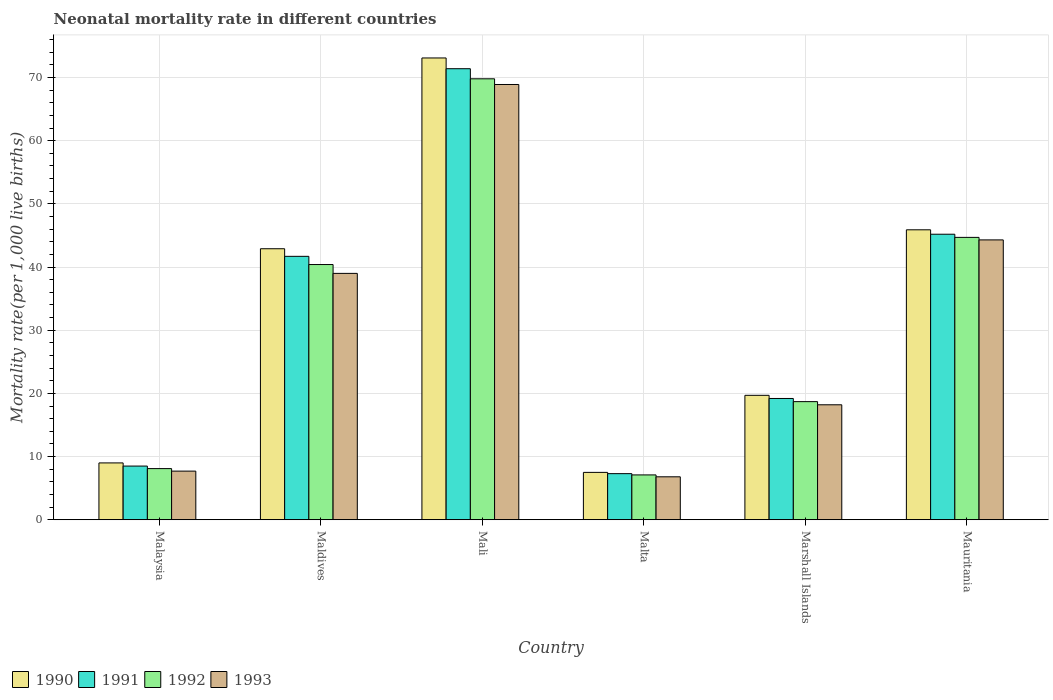How many different coloured bars are there?
Make the answer very short. 4. How many groups of bars are there?
Make the answer very short. 6. What is the label of the 3rd group of bars from the left?
Offer a very short reply. Mali. In how many cases, is the number of bars for a given country not equal to the number of legend labels?
Provide a succinct answer. 0. What is the neonatal mortality rate in 1992 in Mali?
Ensure brevity in your answer.  69.8. Across all countries, what is the maximum neonatal mortality rate in 1990?
Your answer should be compact. 73.1. In which country was the neonatal mortality rate in 1991 maximum?
Provide a short and direct response. Mali. In which country was the neonatal mortality rate in 1993 minimum?
Your response must be concise. Malta. What is the total neonatal mortality rate in 1992 in the graph?
Provide a short and direct response. 188.8. What is the difference between the neonatal mortality rate in 1990 in Maldives and that in Malta?
Give a very brief answer. 35.4. What is the difference between the neonatal mortality rate in 1992 in Mauritania and the neonatal mortality rate in 1991 in Malta?
Your response must be concise. 37.4. What is the average neonatal mortality rate in 1990 per country?
Ensure brevity in your answer.  33.02. What is the difference between the neonatal mortality rate of/in 1992 and neonatal mortality rate of/in 1993 in Malta?
Your response must be concise. 0.3. In how many countries, is the neonatal mortality rate in 1990 greater than 36?
Your response must be concise. 3. What is the ratio of the neonatal mortality rate in 1992 in Mali to that in Malta?
Provide a succinct answer. 9.83. Is the difference between the neonatal mortality rate in 1992 in Malaysia and Maldives greater than the difference between the neonatal mortality rate in 1993 in Malaysia and Maldives?
Your answer should be very brief. No. What is the difference between the highest and the second highest neonatal mortality rate in 1991?
Offer a terse response. -3.5. What is the difference between the highest and the lowest neonatal mortality rate in 1993?
Offer a very short reply. 62.1. Is the sum of the neonatal mortality rate in 1991 in Maldives and Marshall Islands greater than the maximum neonatal mortality rate in 1992 across all countries?
Your answer should be very brief. No. What does the 2nd bar from the right in Mali represents?
Offer a terse response. 1992. How many countries are there in the graph?
Offer a very short reply. 6. What is the difference between two consecutive major ticks on the Y-axis?
Give a very brief answer. 10. Are the values on the major ticks of Y-axis written in scientific E-notation?
Your answer should be very brief. No. Does the graph contain grids?
Provide a short and direct response. Yes. How many legend labels are there?
Your answer should be compact. 4. What is the title of the graph?
Your answer should be compact. Neonatal mortality rate in different countries. Does "2015" appear as one of the legend labels in the graph?
Ensure brevity in your answer.  No. What is the label or title of the X-axis?
Your answer should be very brief. Country. What is the label or title of the Y-axis?
Your answer should be compact. Mortality rate(per 1,0 live births). What is the Mortality rate(per 1,000 live births) of 1993 in Malaysia?
Make the answer very short. 7.7. What is the Mortality rate(per 1,000 live births) of 1990 in Maldives?
Ensure brevity in your answer.  42.9. What is the Mortality rate(per 1,000 live births) in 1991 in Maldives?
Your answer should be very brief. 41.7. What is the Mortality rate(per 1,000 live births) of 1992 in Maldives?
Ensure brevity in your answer.  40.4. What is the Mortality rate(per 1,000 live births) in 1990 in Mali?
Your response must be concise. 73.1. What is the Mortality rate(per 1,000 live births) of 1991 in Mali?
Your response must be concise. 71.4. What is the Mortality rate(per 1,000 live births) of 1992 in Mali?
Provide a short and direct response. 69.8. What is the Mortality rate(per 1,000 live births) of 1993 in Mali?
Your answer should be compact. 68.9. What is the Mortality rate(per 1,000 live births) in 1990 in Malta?
Provide a short and direct response. 7.5. What is the Mortality rate(per 1,000 live births) in 1991 in Malta?
Make the answer very short. 7.3. What is the Mortality rate(per 1,000 live births) in 1990 in Marshall Islands?
Give a very brief answer. 19.7. What is the Mortality rate(per 1,000 live births) of 1990 in Mauritania?
Make the answer very short. 45.9. What is the Mortality rate(per 1,000 live births) of 1991 in Mauritania?
Ensure brevity in your answer.  45.2. What is the Mortality rate(per 1,000 live births) in 1992 in Mauritania?
Your response must be concise. 44.7. What is the Mortality rate(per 1,000 live births) of 1993 in Mauritania?
Ensure brevity in your answer.  44.3. Across all countries, what is the maximum Mortality rate(per 1,000 live births) of 1990?
Ensure brevity in your answer.  73.1. Across all countries, what is the maximum Mortality rate(per 1,000 live births) of 1991?
Your answer should be compact. 71.4. Across all countries, what is the maximum Mortality rate(per 1,000 live births) of 1992?
Offer a very short reply. 69.8. Across all countries, what is the maximum Mortality rate(per 1,000 live births) of 1993?
Offer a terse response. 68.9. Across all countries, what is the minimum Mortality rate(per 1,000 live births) of 1991?
Offer a terse response. 7.3. Across all countries, what is the minimum Mortality rate(per 1,000 live births) in 1992?
Ensure brevity in your answer.  7.1. What is the total Mortality rate(per 1,000 live births) in 1990 in the graph?
Give a very brief answer. 198.1. What is the total Mortality rate(per 1,000 live births) in 1991 in the graph?
Your answer should be very brief. 193.3. What is the total Mortality rate(per 1,000 live births) of 1992 in the graph?
Your answer should be compact. 188.8. What is the total Mortality rate(per 1,000 live births) of 1993 in the graph?
Ensure brevity in your answer.  184.9. What is the difference between the Mortality rate(per 1,000 live births) of 1990 in Malaysia and that in Maldives?
Your answer should be compact. -33.9. What is the difference between the Mortality rate(per 1,000 live births) of 1991 in Malaysia and that in Maldives?
Provide a succinct answer. -33.2. What is the difference between the Mortality rate(per 1,000 live births) in 1992 in Malaysia and that in Maldives?
Keep it short and to the point. -32.3. What is the difference between the Mortality rate(per 1,000 live births) of 1993 in Malaysia and that in Maldives?
Your answer should be very brief. -31.3. What is the difference between the Mortality rate(per 1,000 live births) of 1990 in Malaysia and that in Mali?
Provide a short and direct response. -64.1. What is the difference between the Mortality rate(per 1,000 live births) of 1991 in Malaysia and that in Mali?
Your answer should be very brief. -62.9. What is the difference between the Mortality rate(per 1,000 live births) of 1992 in Malaysia and that in Mali?
Your answer should be very brief. -61.7. What is the difference between the Mortality rate(per 1,000 live births) in 1993 in Malaysia and that in Mali?
Your answer should be very brief. -61.2. What is the difference between the Mortality rate(per 1,000 live births) in 1991 in Malaysia and that in Malta?
Provide a short and direct response. 1.2. What is the difference between the Mortality rate(per 1,000 live births) of 1993 in Malaysia and that in Malta?
Offer a very short reply. 0.9. What is the difference between the Mortality rate(per 1,000 live births) in 1992 in Malaysia and that in Marshall Islands?
Provide a succinct answer. -10.6. What is the difference between the Mortality rate(per 1,000 live births) in 1993 in Malaysia and that in Marshall Islands?
Provide a succinct answer. -10.5. What is the difference between the Mortality rate(per 1,000 live births) of 1990 in Malaysia and that in Mauritania?
Provide a short and direct response. -36.9. What is the difference between the Mortality rate(per 1,000 live births) of 1991 in Malaysia and that in Mauritania?
Offer a very short reply. -36.7. What is the difference between the Mortality rate(per 1,000 live births) in 1992 in Malaysia and that in Mauritania?
Make the answer very short. -36.6. What is the difference between the Mortality rate(per 1,000 live births) in 1993 in Malaysia and that in Mauritania?
Give a very brief answer. -36.6. What is the difference between the Mortality rate(per 1,000 live births) in 1990 in Maldives and that in Mali?
Provide a succinct answer. -30.2. What is the difference between the Mortality rate(per 1,000 live births) of 1991 in Maldives and that in Mali?
Ensure brevity in your answer.  -29.7. What is the difference between the Mortality rate(per 1,000 live births) in 1992 in Maldives and that in Mali?
Provide a short and direct response. -29.4. What is the difference between the Mortality rate(per 1,000 live births) of 1993 in Maldives and that in Mali?
Provide a short and direct response. -29.9. What is the difference between the Mortality rate(per 1,000 live births) of 1990 in Maldives and that in Malta?
Your response must be concise. 35.4. What is the difference between the Mortality rate(per 1,000 live births) of 1991 in Maldives and that in Malta?
Ensure brevity in your answer.  34.4. What is the difference between the Mortality rate(per 1,000 live births) in 1992 in Maldives and that in Malta?
Offer a very short reply. 33.3. What is the difference between the Mortality rate(per 1,000 live births) of 1993 in Maldives and that in Malta?
Make the answer very short. 32.2. What is the difference between the Mortality rate(per 1,000 live births) in 1990 in Maldives and that in Marshall Islands?
Give a very brief answer. 23.2. What is the difference between the Mortality rate(per 1,000 live births) in 1992 in Maldives and that in Marshall Islands?
Give a very brief answer. 21.7. What is the difference between the Mortality rate(per 1,000 live births) of 1993 in Maldives and that in Marshall Islands?
Your response must be concise. 20.8. What is the difference between the Mortality rate(per 1,000 live births) in 1990 in Maldives and that in Mauritania?
Keep it short and to the point. -3. What is the difference between the Mortality rate(per 1,000 live births) in 1990 in Mali and that in Malta?
Your answer should be very brief. 65.6. What is the difference between the Mortality rate(per 1,000 live births) of 1991 in Mali and that in Malta?
Provide a succinct answer. 64.1. What is the difference between the Mortality rate(per 1,000 live births) of 1992 in Mali and that in Malta?
Offer a terse response. 62.7. What is the difference between the Mortality rate(per 1,000 live births) in 1993 in Mali and that in Malta?
Keep it short and to the point. 62.1. What is the difference between the Mortality rate(per 1,000 live births) in 1990 in Mali and that in Marshall Islands?
Your answer should be compact. 53.4. What is the difference between the Mortality rate(per 1,000 live births) of 1991 in Mali and that in Marshall Islands?
Your response must be concise. 52.2. What is the difference between the Mortality rate(per 1,000 live births) in 1992 in Mali and that in Marshall Islands?
Give a very brief answer. 51.1. What is the difference between the Mortality rate(per 1,000 live births) in 1993 in Mali and that in Marshall Islands?
Ensure brevity in your answer.  50.7. What is the difference between the Mortality rate(per 1,000 live births) in 1990 in Mali and that in Mauritania?
Your answer should be compact. 27.2. What is the difference between the Mortality rate(per 1,000 live births) in 1991 in Mali and that in Mauritania?
Offer a very short reply. 26.2. What is the difference between the Mortality rate(per 1,000 live births) in 1992 in Mali and that in Mauritania?
Your answer should be very brief. 25.1. What is the difference between the Mortality rate(per 1,000 live births) of 1993 in Mali and that in Mauritania?
Ensure brevity in your answer.  24.6. What is the difference between the Mortality rate(per 1,000 live births) of 1990 in Malta and that in Marshall Islands?
Give a very brief answer. -12.2. What is the difference between the Mortality rate(per 1,000 live births) of 1991 in Malta and that in Marshall Islands?
Provide a short and direct response. -11.9. What is the difference between the Mortality rate(per 1,000 live births) of 1992 in Malta and that in Marshall Islands?
Offer a terse response. -11.6. What is the difference between the Mortality rate(per 1,000 live births) in 1990 in Malta and that in Mauritania?
Your answer should be very brief. -38.4. What is the difference between the Mortality rate(per 1,000 live births) of 1991 in Malta and that in Mauritania?
Offer a terse response. -37.9. What is the difference between the Mortality rate(per 1,000 live births) of 1992 in Malta and that in Mauritania?
Offer a very short reply. -37.6. What is the difference between the Mortality rate(per 1,000 live births) of 1993 in Malta and that in Mauritania?
Ensure brevity in your answer.  -37.5. What is the difference between the Mortality rate(per 1,000 live births) in 1990 in Marshall Islands and that in Mauritania?
Ensure brevity in your answer.  -26.2. What is the difference between the Mortality rate(per 1,000 live births) of 1993 in Marshall Islands and that in Mauritania?
Keep it short and to the point. -26.1. What is the difference between the Mortality rate(per 1,000 live births) of 1990 in Malaysia and the Mortality rate(per 1,000 live births) of 1991 in Maldives?
Your response must be concise. -32.7. What is the difference between the Mortality rate(per 1,000 live births) of 1990 in Malaysia and the Mortality rate(per 1,000 live births) of 1992 in Maldives?
Make the answer very short. -31.4. What is the difference between the Mortality rate(per 1,000 live births) in 1990 in Malaysia and the Mortality rate(per 1,000 live births) in 1993 in Maldives?
Provide a short and direct response. -30. What is the difference between the Mortality rate(per 1,000 live births) of 1991 in Malaysia and the Mortality rate(per 1,000 live births) of 1992 in Maldives?
Your response must be concise. -31.9. What is the difference between the Mortality rate(per 1,000 live births) in 1991 in Malaysia and the Mortality rate(per 1,000 live births) in 1993 in Maldives?
Provide a succinct answer. -30.5. What is the difference between the Mortality rate(per 1,000 live births) in 1992 in Malaysia and the Mortality rate(per 1,000 live births) in 1993 in Maldives?
Provide a short and direct response. -30.9. What is the difference between the Mortality rate(per 1,000 live births) in 1990 in Malaysia and the Mortality rate(per 1,000 live births) in 1991 in Mali?
Provide a succinct answer. -62.4. What is the difference between the Mortality rate(per 1,000 live births) in 1990 in Malaysia and the Mortality rate(per 1,000 live births) in 1992 in Mali?
Keep it short and to the point. -60.8. What is the difference between the Mortality rate(per 1,000 live births) in 1990 in Malaysia and the Mortality rate(per 1,000 live births) in 1993 in Mali?
Your answer should be compact. -59.9. What is the difference between the Mortality rate(per 1,000 live births) in 1991 in Malaysia and the Mortality rate(per 1,000 live births) in 1992 in Mali?
Provide a short and direct response. -61.3. What is the difference between the Mortality rate(per 1,000 live births) of 1991 in Malaysia and the Mortality rate(per 1,000 live births) of 1993 in Mali?
Your answer should be compact. -60.4. What is the difference between the Mortality rate(per 1,000 live births) in 1992 in Malaysia and the Mortality rate(per 1,000 live births) in 1993 in Mali?
Your answer should be compact. -60.8. What is the difference between the Mortality rate(per 1,000 live births) of 1990 in Malaysia and the Mortality rate(per 1,000 live births) of 1991 in Malta?
Provide a short and direct response. 1.7. What is the difference between the Mortality rate(per 1,000 live births) of 1990 in Malaysia and the Mortality rate(per 1,000 live births) of 1992 in Malta?
Offer a very short reply. 1.9. What is the difference between the Mortality rate(per 1,000 live births) in 1990 in Malaysia and the Mortality rate(per 1,000 live births) in 1993 in Malta?
Your answer should be very brief. 2.2. What is the difference between the Mortality rate(per 1,000 live births) in 1991 in Malaysia and the Mortality rate(per 1,000 live births) in 1992 in Malta?
Provide a short and direct response. 1.4. What is the difference between the Mortality rate(per 1,000 live births) in 1991 in Malaysia and the Mortality rate(per 1,000 live births) in 1993 in Malta?
Ensure brevity in your answer.  1.7. What is the difference between the Mortality rate(per 1,000 live births) of 1990 in Malaysia and the Mortality rate(per 1,000 live births) of 1992 in Marshall Islands?
Make the answer very short. -9.7. What is the difference between the Mortality rate(per 1,000 live births) of 1991 in Malaysia and the Mortality rate(per 1,000 live births) of 1992 in Marshall Islands?
Offer a terse response. -10.2. What is the difference between the Mortality rate(per 1,000 live births) of 1990 in Malaysia and the Mortality rate(per 1,000 live births) of 1991 in Mauritania?
Provide a succinct answer. -36.2. What is the difference between the Mortality rate(per 1,000 live births) in 1990 in Malaysia and the Mortality rate(per 1,000 live births) in 1992 in Mauritania?
Make the answer very short. -35.7. What is the difference between the Mortality rate(per 1,000 live births) of 1990 in Malaysia and the Mortality rate(per 1,000 live births) of 1993 in Mauritania?
Offer a very short reply. -35.3. What is the difference between the Mortality rate(per 1,000 live births) in 1991 in Malaysia and the Mortality rate(per 1,000 live births) in 1992 in Mauritania?
Ensure brevity in your answer.  -36.2. What is the difference between the Mortality rate(per 1,000 live births) of 1991 in Malaysia and the Mortality rate(per 1,000 live births) of 1993 in Mauritania?
Your answer should be compact. -35.8. What is the difference between the Mortality rate(per 1,000 live births) in 1992 in Malaysia and the Mortality rate(per 1,000 live births) in 1993 in Mauritania?
Ensure brevity in your answer.  -36.2. What is the difference between the Mortality rate(per 1,000 live births) of 1990 in Maldives and the Mortality rate(per 1,000 live births) of 1991 in Mali?
Provide a succinct answer. -28.5. What is the difference between the Mortality rate(per 1,000 live births) of 1990 in Maldives and the Mortality rate(per 1,000 live births) of 1992 in Mali?
Offer a very short reply. -26.9. What is the difference between the Mortality rate(per 1,000 live births) of 1990 in Maldives and the Mortality rate(per 1,000 live births) of 1993 in Mali?
Ensure brevity in your answer.  -26. What is the difference between the Mortality rate(per 1,000 live births) of 1991 in Maldives and the Mortality rate(per 1,000 live births) of 1992 in Mali?
Your response must be concise. -28.1. What is the difference between the Mortality rate(per 1,000 live births) in 1991 in Maldives and the Mortality rate(per 1,000 live births) in 1993 in Mali?
Your response must be concise. -27.2. What is the difference between the Mortality rate(per 1,000 live births) of 1992 in Maldives and the Mortality rate(per 1,000 live births) of 1993 in Mali?
Give a very brief answer. -28.5. What is the difference between the Mortality rate(per 1,000 live births) in 1990 in Maldives and the Mortality rate(per 1,000 live births) in 1991 in Malta?
Your answer should be compact. 35.6. What is the difference between the Mortality rate(per 1,000 live births) of 1990 in Maldives and the Mortality rate(per 1,000 live births) of 1992 in Malta?
Offer a very short reply. 35.8. What is the difference between the Mortality rate(per 1,000 live births) in 1990 in Maldives and the Mortality rate(per 1,000 live births) in 1993 in Malta?
Keep it short and to the point. 36.1. What is the difference between the Mortality rate(per 1,000 live births) of 1991 in Maldives and the Mortality rate(per 1,000 live births) of 1992 in Malta?
Provide a short and direct response. 34.6. What is the difference between the Mortality rate(per 1,000 live births) of 1991 in Maldives and the Mortality rate(per 1,000 live births) of 1993 in Malta?
Offer a terse response. 34.9. What is the difference between the Mortality rate(per 1,000 live births) in 1992 in Maldives and the Mortality rate(per 1,000 live births) in 1993 in Malta?
Give a very brief answer. 33.6. What is the difference between the Mortality rate(per 1,000 live births) of 1990 in Maldives and the Mortality rate(per 1,000 live births) of 1991 in Marshall Islands?
Ensure brevity in your answer.  23.7. What is the difference between the Mortality rate(per 1,000 live births) of 1990 in Maldives and the Mortality rate(per 1,000 live births) of 1992 in Marshall Islands?
Your answer should be very brief. 24.2. What is the difference between the Mortality rate(per 1,000 live births) of 1990 in Maldives and the Mortality rate(per 1,000 live births) of 1993 in Marshall Islands?
Make the answer very short. 24.7. What is the difference between the Mortality rate(per 1,000 live births) in 1991 in Maldives and the Mortality rate(per 1,000 live births) in 1993 in Marshall Islands?
Give a very brief answer. 23.5. What is the difference between the Mortality rate(per 1,000 live births) of 1990 in Maldives and the Mortality rate(per 1,000 live births) of 1991 in Mauritania?
Provide a short and direct response. -2.3. What is the difference between the Mortality rate(per 1,000 live births) in 1990 in Maldives and the Mortality rate(per 1,000 live births) in 1993 in Mauritania?
Keep it short and to the point. -1.4. What is the difference between the Mortality rate(per 1,000 live births) in 1991 in Maldives and the Mortality rate(per 1,000 live births) in 1993 in Mauritania?
Your response must be concise. -2.6. What is the difference between the Mortality rate(per 1,000 live births) of 1990 in Mali and the Mortality rate(per 1,000 live births) of 1991 in Malta?
Make the answer very short. 65.8. What is the difference between the Mortality rate(per 1,000 live births) in 1990 in Mali and the Mortality rate(per 1,000 live births) in 1992 in Malta?
Your response must be concise. 66. What is the difference between the Mortality rate(per 1,000 live births) in 1990 in Mali and the Mortality rate(per 1,000 live births) in 1993 in Malta?
Keep it short and to the point. 66.3. What is the difference between the Mortality rate(per 1,000 live births) of 1991 in Mali and the Mortality rate(per 1,000 live births) of 1992 in Malta?
Ensure brevity in your answer.  64.3. What is the difference between the Mortality rate(per 1,000 live births) of 1991 in Mali and the Mortality rate(per 1,000 live births) of 1993 in Malta?
Your answer should be very brief. 64.6. What is the difference between the Mortality rate(per 1,000 live births) of 1992 in Mali and the Mortality rate(per 1,000 live births) of 1993 in Malta?
Ensure brevity in your answer.  63. What is the difference between the Mortality rate(per 1,000 live births) in 1990 in Mali and the Mortality rate(per 1,000 live births) in 1991 in Marshall Islands?
Give a very brief answer. 53.9. What is the difference between the Mortality rate(per 1,000 live births) in 1990 in Mali and the Mortality rate(per 1,000 live births) in 1992 in Marshall Islands?
Your response must be concise. 54.4. What is the difference between the Mortality rate(per 1,000 live births) in 1990 in Mali and the Mortality rate(per 1,000 live births) in 1993 in Marshall Islands?
Your response must be concise. 54.9. What is the difference between the Mortality rate(per 1,000 live births) in 1991 in Mali and the Mortality rate(per 1,000 live births) in 1992 in Marshall Islands?
Your answer should be very brief. 52.7. What is the difference between the Mortality rate(per 1,000 live births) of 1991 in Mali and the Mortality rate(per 1,000 live births) of 1993 in Marshall Islands?
Give a very brief answer. 53.2. What is the difference between the Mortality rate(per 1,000 live births) in 1992 in Mali and the Mortality rate(per 1,000 live births) in 1993 in Marshall Islands?
Keep it short and to the point. 51.6. What is the difference between the Mortality rate(per 1,000 live births) of 1990 in Mali and the Mortality rate(per 1,000 live births) of 1991 in Mauritania?
Provide a succinct answer. 27.9. What is the difference between the Mortality rate(per 1,000 live births) in 1990 in Mali and the Mortality rate(per 1,000 live births) in 1992 in Mauritania?
Keep it short and to the point. 28.4. What is the difference between the Mortality rate(per 1,000 live births) in 1990 in Mali and the Mortality rate(per 1,000 live births) in 1993 in Mauritania?
Ensure brevity in your answer.  28.8. What is the difference between the Mortality rate(per 1,000 live births) in 1991 in Mali and the Mortality rate(per 1,000 live births) in 1992 in Mauritania?
Offer a terse response. 26.7. What is the difference between the Mortality rate(per 1,000 live births) of 1991 in Mali and the Mortality rate(per 1,000 live births) of 1993 in Mauritania?
Offer a terse response. 27.1. What is the difference between the Mortality rate(per 1,000 live births) of 1992 in Mali and the Mortality rate(per 1,000 live births) of 1993 in Mauritania?
Provide a short and direct response. 25.5. What is the difference between the Mortality rate(per 1,000 live births) in 1991 in Malta and the Mortality rate(per 1,000 live births) in 1992 in Marshall Islands?
Make the answer very short. -11.4. What is the difference between the Mortality rate(per 1,000 live births) of 1991 in Malta and the Mortality rate(per 1,000 live births) of 1993 in Marshall Islands?
Provide a succinct answer. -10.9. What is the difference between the Mortality rate(per 1,000 live births) in 1990 in Malta and the Mortality rate(per 1,000 live births) in 1991 in Mauritania?
Provide a short and direct response. -37.7. What is the difference between the Mortality rate(per 1,000 live births) in 1990 in Malta and the Mortality rate(per 1,000 live births) in 1992 in Mauritania?
Offer a very short reply. -37.2. What is the difference between the Mortality rate(per 1,000 live births) in 1990 in Malta and the Mortality rate(per 1,000 live births) in 1993 in Mauritania?
Your response must be concise. -36.8. What is the difference between the Mortality rate(per 1,000 live births) of 1991 in Malta and the Mortality rate(per 1,000 live births) of 1992 in Mauritania?
Give a very brief answer. -37.4. What is the difference between the Mortality rate(per 1,000 live births) in 1991 in Malta and the Mortality rate(per 1,000 live births) in 1993 in Mauritania?
Offer a very short reply. -37. What is the difference between the Mortality rate(per 1,000 live births) of 1992 in Malta and the Mortality rate(per 1,000 live births) of 1993 in Mauritania?
Your answer should be very brief. -37.2. What is the difference between the Mortality rate(per 1,000 live births) in 1990 in Marshall Islands and the Mortality rate(per 1,000 live births) in 1991 in Mauritania?
Give a very brief answer. -25.5. What is the difference between the Mortality rate(per 1,000 live births) in 1990 in Marshall Islands and the Mortality rate(per 1,000 live births) in 1992 in Mauritania?
Your answer should be very brief. -25. What is the difference between the Mortality rate(per 1,000 live births) of 1990 in Marshall Islands and the Mortality rate(per 1,000 live births) of 1993 in Mauritania?
Your response must be concise. -24.6. What is the difference between the Mortality rate(per 1,000 live births) in 1991 in Marshall Islands and the Mortality rate(per 1,000 live births) in 1992 in Mauritania?
Give a very brief answer. -25.5. What is the difference between the Mortality rate(per 1,000 live births) in 1991 in Marshall Islands and the Mortality rate(per 1,000 live births) in 1993 in Mauritania?
Your answer should be very brief. -25.1. What is the difference between the Mortality rate(per 1,000 live births) of 1992 in Marshall Islands and the Mortality rate(per 1,000 live births) of 1993 in Mauritania?
Your response must be concise. -25.6. What is the average Mortality rate(per 1,000 live births) of 1990 per country?
Offer a terse response. 33.02. What is the average Mortality rate(per 1,000 live births) in 1991 per country?
Offer a very short reply. 32.22. What is the average Mortality rate(per 1,000 live births) of 1992 per country?
Provide a short and direct response. 31.47. What is the average Mortality rate(per 1,000 live births) of 1993 per country?
Your answer should be compact. 30.82. What is the difference between the Mortality rate(per 1,000 live births) in 1990 and Mortality rate(per 1,000 live births) in 1991 in Malaysia?
Make the answer very short. 0.5. What is the difference between the Mortality rate(per 1,000 live births) in 1990 and Mortality rate(per 1,000 live births) in 1993 in Malaysia?
Your response must be concise. 1.3. What is the difference between the Mortality rate(per 1,000 live births) in 1991 and Mortality rate(per 1,000 live births) in 1992 in Malaysia?
Offer a very short reply. 0.4. What is the difference between the Mortality rate(per 1,000 live births) of 1991 and Mortality rate(per 1,000 live births) of 1993 in Malaysia?
Your answer should be compact. 0.8. What is the difference between the Mortality rate(per 1,000 live births) in 1990 and Mortality rate(per 1,000 live births) in 1991 in Maldives?
Provide a succinct answer. 1.2. What is the difference between the Mortality rate(per 1,000 live births) of 1990 and Mortality rate(per 1,000 live births) of 1993 in Maldives?
Your response must be concise. 3.9. What is the difference between the Mortality rate(per 1,000 live births) in 1991 and Mortality rate(per 1,000 live births) in 1992 in Maldives?
Offer a terse response. 1.3. What is the difference between the Mortality rate(per 1,000 live births) of 1991 and Mortality rate(per 1,000 live births) of 1993 in Maldives?
Offer a terse response. 2.7. What is the difference between the Mortality rate(per 1,000 live births) of 1992 and Mortality rate(per 1,000 live births) of 1993 in Maldives?
Offer a very short reply. 1.4. What is the difference between the Mortality rate(per 1,000 live births) of 1990 and Mortality rate(per 1,000 live births) of 1991 in Mali?
Ensure brevity in your answer.  1.7. What is the difference between the Mortality rate(per 1,000 live births) of 1990 and Mortality rate(per 1,000 live births) of 1993 in Mali?
Offer a terse response. 4.2. What is the difference between the Mortality rate(per 1,000 live births) of 1990 and Mortality rate(per 1,000 live births) of 1991 in Malta?
Provide a short and direct response. 0.2. What is the difference between the Mortality rate(per 1,000 live births) of 1990 and Mortality rate(per 1,000 live births) of 1992 in Malta?
Provide a succinct answer. 0.4. What is the difference between the Mortality rate(per 1,000 live births) in 1990 and Mortality rate(per 1,000 live births) in 1993 in Marshall Islands?
Make the answer very short. 1.5. What is the difference between the Mortality rate(per 1,000 live births) of 1991 and Mortality rate(per 1,000 live births) of 1992 in Marshall Islands?
Your response must be concise. 0.5. What is the difference between the Mortality rate(per 1,000 live births) in 1990 and Mortality rate(per 1,000 live births) in 1992 in Mauritania?
Your response must be concise. 1.2. What is the difference between the Mortality rate(per 1,000 live births) in 1990 and Mortality rate(per 1,000 live births) in 1993 in Mauritania?
Offer a terse response. 1.6. What is the difference between the Mortality rate(per 1,000 live births) of 1991 and Mortality rate(per 1,000 live births) of 1992 in Mauritania?
Your answer should be compact. 0.5. What is the difference between the Mortality rate(per 1,000 live births) in 1991 and Mortality rate(per 1,000 live births) in 1993 in Mauritania?
Offer a very short reply. 0.9. What is the difference between the Mortality rate(per 1,000 live births) of 1992 and Mortality rate(per 1,000 live births) of 1993 in Mauritania?
Give a very brief answer. 0.4. What is the ratio of the Mortality rate(per 1,000 live births) in 1990 in Malaysia to that in Maldives?
Keep it short and to the point. 0.21. What is the ratio of the Mortality rate(per 1,000 live births) of 1991 in Malaysia to that in Maldives?
Offer a very short reply. 0.2. What is the ratio of the Mortality rate(per 1,000 live births) in 1992 in Malaysia to that in Maldives?
Your answer should be very brief. 0.2. What is the ratio of the Mortality rate(per 1,000 live births) of 1993 in Malaysia to that in Maldives?
Your answer should be very brief. 0.2. What is the ratio of the Mortality rate(per 1,000 live births) of 1990 in Malaysia to that in Mali?
Provide a succinct answer. 0.12. What is the ratio of the Mortality rate(per 1,000 live births) in 1991 in Malaysia to that in Mali?
Offer a very short reply. 0.12. What is the ratio of the Mortality rate(per 1,000 live births) in 1992 in Malaysia to that in Mali?
Provide a succinct answer. 0.12. What is the ratio of the Mortality rate(per 1,000 live births) in 1993 in Malaysia to that in Mali?
Offer a terse response. 0.11. What is the ratio of the Mortality rate(per 1,000 live births) in 1990 in Malaysia to that in Malta?
Offer a terse response. 1.2. What is the ratio of the Mortality rate(per 1,000 live births) in 1991 in Malaysia to that in Malta?
Offer a terse response. 1.16. What is the ratio of the Mortality rate(per 1,000 live births) in 1992 in Malaysia to that in Malta?
Ensure brevity in your answer.  1.14. What is the ratio of the Mortality rate(per 1,000 live births) of 1993 in Malaysia to that in Malta?
Offer a terse response. 1.13. What is the ratio of the Mortality rate(per 1,000 live births) in 1990 in Malaysia to that in Marshall Islands?
Your answer should be compact. 0.46. What is the ratio of the Mortality rate(per 1,000 live births) of 1991 in Malaysia to that in Marshall Islands?
Offer a terse response. 0.44. What is the ratio of the Mortality rate(per 1,000 live births) of 1992 in Malaysia to that in Marshall Islands?
Your response must be concise. 0.43. What is the ratio of the Mortality rate(per 1,000 live births) in 1993 in Malaysia to that in Marshall Islands?
Keep it short and to the point. 0.42. What is the ratio of the Mortality rate(per 1,000 live births) in 1990 in Malaysia to that in Mauritania?
Offer a terse response. 0.2. What is the ratio of the Mortality rate(per 1,000 live births) of 1991 in Malaysia to that in Mauritania?
Give a very brief answer. 0.19. What is the ratio of the Mortality rate(per 1,000 live births) in 1992 in Malaysia to that in Mauritania?
Ensure brevity in your answer.  0.18. What is the ratio of the Mortality rate(per 1,000 live births) in 1993 in Malaysia to that in Mauritania?
Offer a terse response. 0.17. What is the ratio of the Mortality rate(per 1,000 live births) in 1990 in Maldives to that in Mali?
Your answer should be compact. 0.59. What is the ratio of the Mortality rate(per 1,000 live births) of 1991 in Maldives to that in Mali?
Offer a very short reply. 0.58. What is the ratio of the Mortality rate(per 1,000 live births) in 1992 in Maldives to that in Mali?
Make the answer very short. 0.58. What is the ratio of the Mortality rate(per 1,000 live births) of 1993 in Maldives to that in Mali?
Keep it short and to the point. 0.57. What is the ratio of the Mortality rate(per 1,000 live births) in 1990 in Maldives to that in Malta?
Give a very brief answer. 5.72. What is the ratio of the Mortality rate(per 1,000 live births) of 1991 in Maldives to that in Malta?
Offer a very short reply. 5.71. What is the ratio of the Mortality rate(per 1,000 live births) of 1992 in Maldives to that in Malta?
Ensure brevity in your answer.  5.69. What is the ratio of the Mortality rate(per 1,000 live births) in 1993 in Maldives to that in Malta?
Offer a terse response. 5.74. What is the ratio of the Mortality rate(per 1,000 live births) of 1990 in Maldives to that in Marshall Islands?
Provide a succinct answer. 2.18. What is the ratio of the Mortality rate(per 1,000 live births) of 1991 in Maldives to that in Marshall Islands?
Your response must be concise. 2.17. What is the ratio of the Mortality rate(per 1,000 live births) in 1992 in Maldives to that in Marshall Islands?
Provide a succinct answer. 2.16. What is the ratio of the Mortality rate(per 1,000 live births) in 1993 in Maldives to that in Marshall Islands?
Provide a short and direct response. 2.14. What is the ratio of the Mortality rate(per 1,000 live births) in 1990 in Maldives to that in Mauritania?
Provide a short and direct response. 0.93. What is the ratio of the Mortality rate(per 1,000 live births) of 1991 in Maldives to that in Mauritania?
Give a very brief answer. 0.92. What is the ratio of the Mortality rate(per 1,000 live births) of 1992 in Maldives to that in Mauritania?
Your answer should be compact. 0.9. What is the ratio of the Mortality rate(per 1,000 live births) in 1993 in Maldives to that in Mauritania?
Your answer should be compact. 0.88. What is the ratio of the Mortality rate(per 1,000 live births) in 1990 in Mali to that in Malta?
Give a very brief answer. 9.75. What is the ratio of the Mortality rate(per 1,000 live births) of 1991 in Mali to that in Malta?
Your answer should be very brief. 9.78. What is the ratio of the Mortality rate(per 1,000 live births) in 1992 in Mali to that in Malta?
Your answer should be compact. 9.83. What is the ratio of the Mortality rate(per 1,000 live births) of 1993 in Mali to that in Malta?
Your answer should be very brief. 10.13. What is the ratio of the Mortality rate(per 1,000 live births) of 1990 in Mali to that in Marshall Islands?
Offer a very short reply. 3.71. What is the ratio of the Mortality rate(per 1,000 live births) of 1991 in Mali to that in Marshall Islands?
Ensure brevity in your answer.  3.72. What is the ratio of the Mortality rate(per 1,000 live births) of 1992 in Mali to that in Marshall Islands?
Your answer should be compact. 3.73. What is the ratio of the Mortality rate(per 1,000 live births) of 1993 in Mali to that in Marshall Islands?
Offer a terse response. 3.79. What is the ratio of the Mortality rate(per 1,000 live births) in 1990 in Mali to that in Mauritania?
Your answer should be compact. 1.59. What is the ratio of the Mortality rate(per 1,000 live births) of 1991 in Mali to that in Mauritania?
Give a very brief answer. 1.58. What is the ratio of the Mortality rate(per 1,000 live births) of 1992 in Mali to that in Mauritania?
Your answer should be compact. 1.56. What is the ratio of the Mortality rate(per 1,000 live births) of 1993 in Mali to that in Mauritania?
Keep it short and to the point. 1.56. What is the ratio of the Mortality rate(per 1,000 live births) of 1990 in Malta to that in Marshall Islands?
Your answer should be compact. 0.38. What is the ratio of the Mortality rate(per 1,000 live births) of 1991 in Malta to that in Marshall Islands?
Ensure brevity in your answer.  0.38. What is the ratio of the Mortality rate(per 1,000 live births) in 1992 in Malta to that in Marshall Islands?
Provide a short and direct response. 0.38. What is the ratio of the Mortality rate(per 1,000 live births) of 1993 in Malta to that in Marshall Islands?
Make the answer very short. 0.37. What is the ratio of the Mortality rate(per 1,000 live births) of 1990 in Malta to that in Mauritania?
Your answer should be very brief. 0.16. What is the ratio of the Mortality rate(per 1,000 live births) in 1991 in Malta to that in Mauritania?
Give a very brief answer. 0.16. What is the ratio of the Mortality rate(per 1,000 live births) in 1992 in Malta to that in Mauritania?
Make the answer very short. 0.16. What is the ratio of the Mortality rate(per 1,000 live births) of 1993 in Malta to that in Mauritania?
Your response must be concise. 0.15. What is the ratio of the Mortality rate(per 1,000 live births) of 1990 in Marshall Islands to that in Mauritania?
Your response must be concise. 0.43. What is the ratio of the Mortality rate(per 1,000 live births) in 1991 in Marshall Islands to that in Mauritania?
Your answer should be compact. 0.42. What is the ratio of the Mortality rate(per 1,000 live births) of 1992 in Marshall Islands to that in Mauritania?
Provide a short and direct response. 0.42. What is the ratio of the Mortality rate(per 1,000 live births) of 1993 in Marshall Islands to that in Mauritania?
Offer a terse response. 0.41. What is the difference between the highest and the second highest Mortality rate(per 1,000 live births) in 1990?
Your answer should be compact. 27.2. What is the difference between the highest and the second highest Mortality rate(per 1,000 live births) of 1991?
Your answer should be very brief. 26.2. What is the difference between the highest and the second highest Mortality rate(per 1,000 live births) in 1992?
Ensure brevity in your answer.  25.1. What is the difference between the highest and the second highest Mortality rate(per 1,000 live births) in 1993?
Make the answer very short. 24.6. What is the difference between the highest and the lowest Mortality rate(per 1,000 live births) in 1990?
Provide a succinct answer. 65.6. What is the difference between the highest and the lowest Mortality rate(per 1,000 live births) in 1991?
Your response must be concise. 64.1. What is the difference between the highest and the lowest Mortality rate(per 1,000 live births) in 1992?
Ensure brevity in your answer.  62.7. What is the difference between the highest and the lowest Mortality rate(per 1,000 live births) in 1993?
Ensure brevity in your answer.  62.1. 